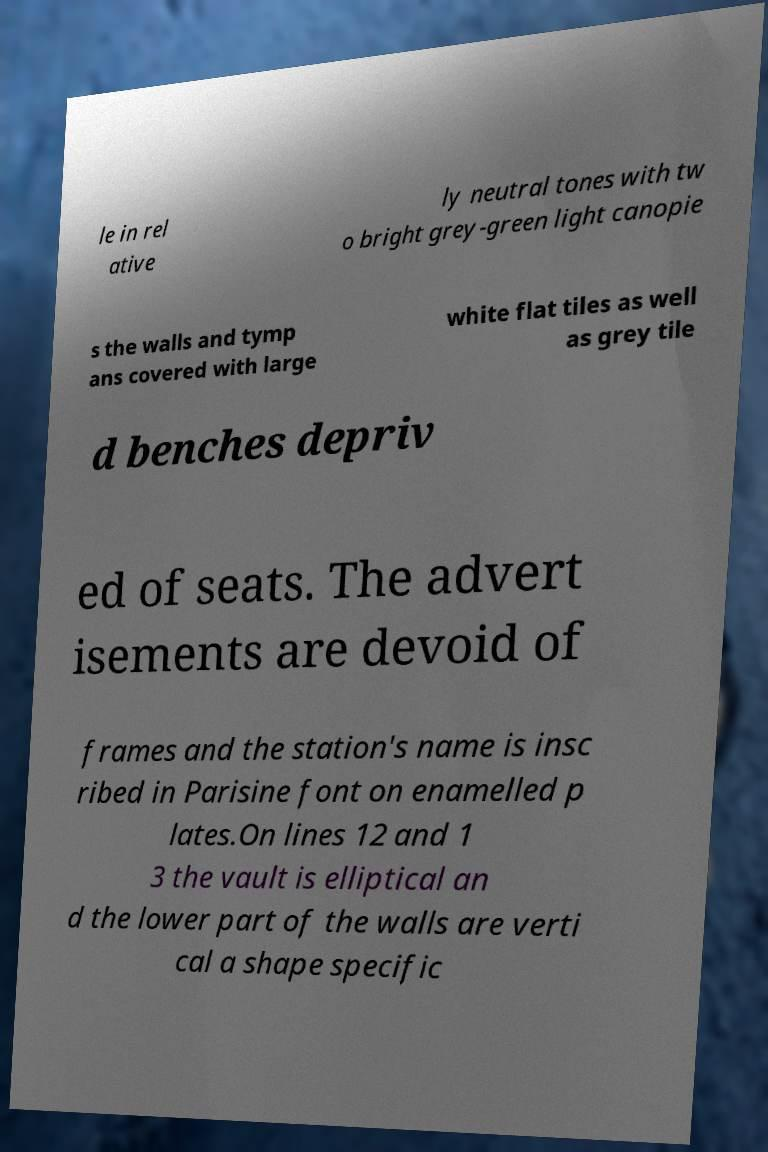Can you read and provide the text displayed in the image?This photo seems to have some interesting text. Can you extract and type it out for me? le in rel ative ly neutral tones with tw o bright grey-green light canopie s the walls and tymp ans covered with large white flat tiles as well as grey tile d benches depriv ed of seats. The advert isements are devoid of frames and the station's name is insc ribed in Parisine font on enamelled p lates.On lines 12 and 1 3 the vault is elliptical an d the lower part of the walls are verti cal a shape specific 